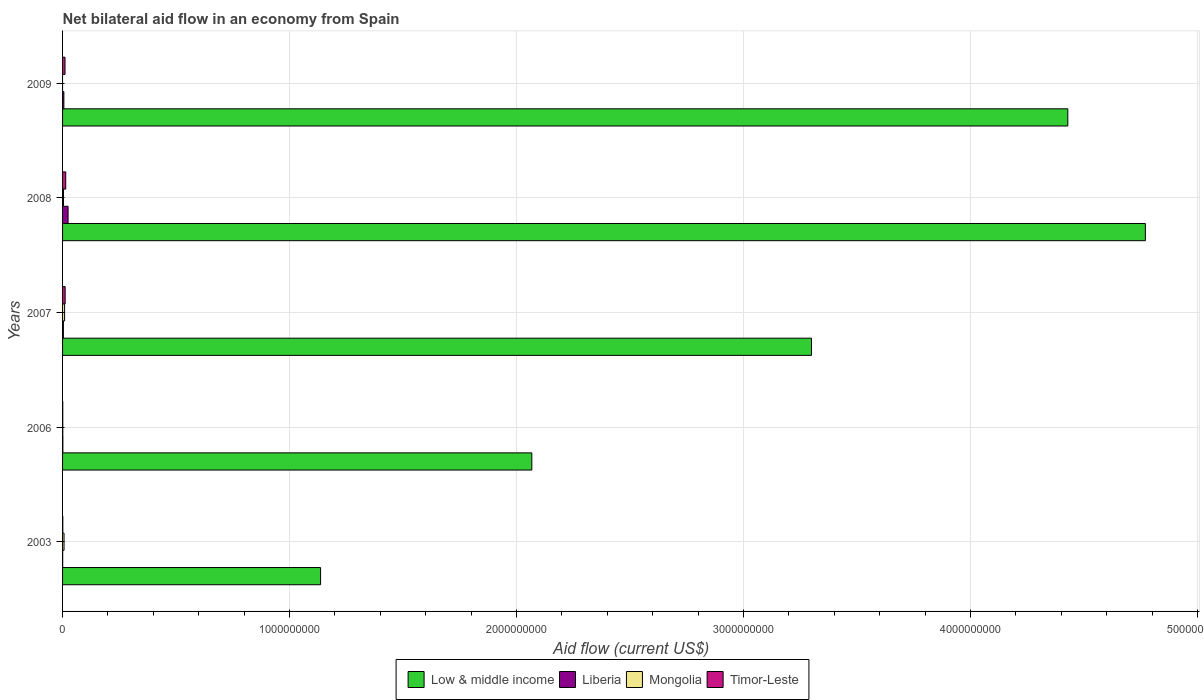How many different coloured bars are there?
Make the answer very short. 4. How many groups of bars are there?
Offer a very short reply. 5. Are the number of bars on each tick of the Y-axis equal?
Your answer should be very brief. No. How many bars are there on the 1st tick from the top?
Ensure brevity in your answer.  3. What is the label of the 3rd group of bars from the top?
Your answer should be compact. 2007. What is the net bilateral aid flow in Mongolia in 2006?
Provide a succinct answer. 8.90e+05. Across all years, what is the maximum net bilateral aid flow in Liberia?
Provide a short and direct response. 2.43e+07. In which year was the net bilateral aid flow in Liberia maximum?
Give a very brief answer. 2008. What is the total net bilateral aid flow in Liberia in the graph?
Provide a short and direct response. 3.53e+07. What is the difference between the net bilateral aid flow in Low & middle income in 2006 and that in 2007?
Provide a succinct answer. -1.23e+09. What is the difference between the net bilateral aid flow in Mongolia in 2006 and the net bilateral aid flow in Timor-Leste in 2007?
Your answer should be compact. -1.05e+07. What is the average net bilateral aid flow in Low & middle income per year?
Make the answer very short. 3.14e+09. In the year 2008, what is the difference between the net bilateral aid flow in Mongolia and net bilateral aid flow in Timor-Leste?
Your response must be concise. -9.91e+06. What is the ratio of the net bilateral aid flow in Timor-Leste in 2003 to that in 2009?
Provide a succinct answer. 0.1. Is the difference between the net bilateral aid flow in Mongolia in 2006 and 2008 greater than the difference between the net bilateral aid flow in Timor-Leste in 2006 and 2008?
Give a very brief answer. Yes. What is the difference between the highest and the second highest net bilateral aid flow in Mongolia?
Your response must be concise. 2.44e+06. What is the difference between the highest and the lowest net bilateral aid flow in Timor-Leste?
Offer a very short reply. 1.32e+07. Is it the case that in every year, the sum of the net bilateral aid flow in Liberia and net bilateral aid flow in Timor-Leste is greater than the sum of net bilateral aid flow in Low & middle income and net bilateral aid flow in Mongolia?
Give a very brief answer. No. Is it the case that in every year, the sum of the net bilateral aid flow in Low & middle income and net bilateral aid flow in Mongolia is greater than the net bilateral aid flow in Timor-Leste?
Keep it short and to the point. Yes. How many years are there in the graph?
Offer a very short reply. 5. What is the difference between two consecutive major ticks on the X-axis?
Give a very brief answer. 1.00e+09. Are the values on the major ticks of X-axis written in scientific E-notation?
Ensure brevity in your answer.  No. Does the graph contain grids?
Provide a short and direct response. Yes. How many legend labels are there?
Make the answer very short. 4. How are the legend labels stacked?
Ensure brevity in your answer.  Horizontal. What is the title of the graph?
Ensure brevity in your answer.  Net bilateral aid flow in an economy from Spain. What is the label or title of the X-axis?
Your answer should be compact. Aid flow (current US$). What is the label or title of the Y-axis?
Your response must be concise. Years. What is the Aid flow (current US$) of Low & middle income in 2003?
Your response must be concise. 1.14e+09. What is the Aid flow (current US$) of Mongolia in 2003?
Give a very brief answer. 6.52e+06. What is the Aid flow (current US$) of Timor-Leste in 2003?
Provide a short and direct response. 1.03e+06. What is the Aid flow (current US$) of Low & middle income in 2006?
Provide a succinct answer. 2.07e+09. What is the Aid flow (current US$) in Liberia in 2006?
Provide a short and direct response. 1.26e+06. What is the Aid flow (current US$) of Mongolia in 2006?
Give a very brief answer. 8.90e+05. What is the Aid flow (current US$) of Timor-Leste in 2006?
Ensure brevity in your answer.  7.90e+05. What is the Aid flow (current US$) of Low & middle income in 2007?
Your answer should be compact. 3.30e+09. What is the Aid flow (current US$) in Liberia in 2007?
Make the answer very short. 3.55e+06. What is the Aid flow (current US$) of Mongolia in 2007?
Offer a very short reply. 8.96e+06. What is the Aid flow (current US$) in Timor-Leste in 2007?
Ensure brevity in your answer.  1.14e+07. What is the Aid flow (current US$) of Low & middle income in 2008?
Keep it short and to the point. 4.77e+09. What is the Aid flow (current US$) of Liberia in 2008?
Provide a succinct answer. 2.43e+07. What is the Aid flow (current US$) in Mongolia in 2008?
Offer a terse response. 4.05e+06. What is the Aid flow (current US$) of Timor-Leste in 2008?
Keep it short and to the point. 1.40e+07. What is the Aid flow (current US$) in Low & middle income in 2009?
Your response must be concise. 4.43e+09. What is the Aid flow (current US$) of Liberia in 2009?
Your response must be concise. 5.75e+06. What is the Aid flow (current US$) of Mongolia in 2009?
Your answer should be very brief. 0. What is the Aid flow (current US$) in Timor-Leste in 2009?
Provide a succinct answer. 1.08e+07. Across all years, what is the maximum Aid flow (current US$) of Low & middle income?
Provide a succinct answer. 4.77e+09. Across all years, what is the maximum Aid flow (current US$) of Liberia?
Keep it short and to the point. 2.43e+07. Across all years, what is the maximum Aid flow (current US$) of Mongolia?
Ensure brevity in your answer.  8.96e+06. Across all years, what is the maximum Aid flow (current US$) in Timor-Leste?
Offer a very short reply. 1.40e+07. Across all years, what is the minimum Aid flow (current US$) in Low & middle income?
Ensure brevity in your answer.  1.14e+09. Across all years, what is the minimum Aid flow (current US$) of Liberia?
Offer a terse response. 4.60e+05. Across all years, what is the minimum Aid flow (current US$) in Timor-Leste?
Offer a terse response. 7.90e+05. What is the total Aid flow (current US$) in Low & middle income in the graph?
Keep it short and to the point. 1.57e+1. What is the total Aid flow (current US$) of Liberia in the graph?
Provide a short and direct response. 3.53e+07. What is the total Aid flow (current US$) in Mongolia in the graph?
Your answer should be very brief. 2.04e+07. What is the total Aid flow (current US$) in Timor-Leste in the graph?
Make the answer very short. 3.80e+07. What is the difference between the Aid flow (current US$) in Low & middle income in 2003 and that in 2006?
Provide a short and direct response. -9.31e+08. What is the difference between the Aid flow (current US$) in Liberia in 2003 and that in 2006?
Provide a short and direct response. -8.00e+05. What is the difference between the Aid flow (current US$) in Mongolia in 2003 and that in 2006?
Offer a terse response. 5.63e+06. What is the difference between the Aid flow (current US$) in Timor-Leste in 2003 and that in 2006?
Provide a succinct answer. 2.40e+05. What is the difference between the Aid flow (current US$) in Low & middle income in 2003 and that in 2007?
Make the answer very short. -2.16e+09. What is the difference between the Aid flow (current US$) in Liberia in 2003 and that in 2007?
Offer a terse response. -3.09e+06. What is the difference between the Aid flow (current US$) in Mongolia in 2003 and that in 2007?
Ensure brevity in your answer.  -2.44e+06. What is the difference between the Aid flow (current US$) in Timor-Leste in 2003 and that in 2007?
Offer a terse response. -1.04e+07. What is the difference between the Aid flow (current US$) of Low & middle income in 2003 and that in 2008?
Your response must be concise. -3.63e+09. What is the difference between the Aid flow (current US$) in Liberia in 2003 and that in 2008?
Your answer should be compact. -2.38e+07. What is the difference between the Aid flow (current US$) of Mongolia in 2003 and that in 2008?
Your answer should be very brief. 2.47e+06. What is the difference between the Aid flow (current US$) in Timor-Leste in 2003 and that in 2008?
Provide a short and direct response. -1.29e+07. What is the difference between the Aid flow (current US$) in Low & middle income in 2003 and that in 2009?
Your answer should be very brief. -3.29e+09. What is the difference between the Aid flow (current US$) in Liberia in 2003 and that in 2009?
Offer a terse response. -5.29e+06. What is the difference between the Aid flow (current US$) in Timor-Leste in 2003 and that in 2009?
Give a very brief answer. -9.79e+06. What is the difference between the Aid flow (current US$) in Low & middle income in 2006 and that in 2007?
Make the answer very short. -1.23e+09. What is the difference between the Aid flow (current US$) of Liberia in 2006 and that in 2007?
Provide a short and direct response. -2.29e+06. What is the difference between the Aid flow (current US$) of Mongolia in 2006 and that in 2007?
Make the answer very short. -8.07e+06. What is the difference between the Aid flow (current US$) in Timor-Leste in 2006 and that in 2007?
Your answer should be compact. -1.06e+07. What is the difference between the Aid flow (current US$) in Low & middle income in 2006 and that in 2008?
Keep it short and to the point. -2.70e+09. What is the difference between the Aid flow (current US$) in Liberia in 2006 and that in 2008?
Make the answer very short. -2.30e+07. What is the difference between the Aid flow (current US$) in Mongolia in 2006 and that in 2008?
Your answer should be compact. -3.16e+06. What is the difference between the Aid flow (current US$) in Timor-Leste in 2006 and that in 2008?
Ensure brevity in your answer.  -1.32e+07. What is the difference between the Aid flow (current US$) of Low & middle income in 2006 and that in 2009?
Offer a very short reply. -2.36e+09. What is the difference between the Aid flow (current US$) of Liberia in 2006 and that in 2009?
Offer a terse response. -4.49e+06. What is the difference between the Aid flow (current US$) in Timor-Leste in 2006 and that in 2009?
Offer a very short reply. -1.00e+07. What is the difference between the Aid flow (current US$) of Low & middle income in 2007 and that in 2008?
Offer a terse response. -1.47e+09. What is the difference between the Aid flow (current US$) of Liberia in 2007 and that in 2008?
Provide a short and direct response. -2.07e+07. What is the difference between the Aid flow (current US$) in Mongolia in 2007 and that in 2008?
Keep it short and to the point. 4.91e+06. What is the difference between the Aid flow (current US$) in Timor-Leste in 2007 and that in 2008?
Make the answer very short. -2.55e+06. What is the difference between the Aid flow (current US$) of Low & middle income in 2007 and that in 2009?
Your response must be concise. -1.13e+09. What is the difference between the Aid flow (current US$) in Liberia in 2007 and that in 2009?
Provide a succinct answer. -2.20e+06. What is the difference between the Aid flow (current US$) of Timor-Leste in 2007 and that in 2009?
Your answer should be very brief. 5.90e+05. What is the difference between the Aid flow (current US$) of Low & middle income in 2008 and that in 2009?
Your answer should be very brief. 3.42e+08. What is the difference between the Aid flow (current US$) of Liberia in 2008 and that in 2009?
Your response must be concise. 1.85e+07. What is the difference between the Aid flow (current US$) in Timor-Leste in 2008 and that in 2009?
Your answer should be very brief. 3.14e+06. What is the difference between the Aid flow (current US$) in Low & middle income in 2003 and the Aid flow (current US$) in Liberia in 2006?
Your response must be concise. 1.14e+09. What is the difference between the Aid flow (current US$) in Low & middle income in 2003 and the Aid flow (current US$) in Mongolia in 2006?
Your answer should be compact. 1.14e+09. What is the difference between the Aid flow (current US$) of Low & middle income in 2003 and the Aid flow (current US$) of Timor-Leste in 2006?
Your answer should be very brief. 1.14e+09. What is the difference between the Aid flow (current US$) of Liberia in 2003 and the Aid flow (current US$) of Mongolia in 2006?
Ensure brevity in your answer.  -4.30e+05. What is the difference between the Aid flow (current US$) in Liberia in 2003 and the Aid flow (current US$) in Timor-Leste in 2006?
Make the answer very short. -3.30e+05. What is the difference between the Aid flow (current US$) of Mongolia in 2003 and the Aid flow (current US$) of Timor-Leste in 2006?
Offer a very short reply. 5.73e+06. What is the difference between the Aid flow (current US$) in Low & middle income in 2003 and the Aid flow (current US$) in Liberia in 2007?
Make the answer very short. 1.13e+09. What is the difference between the Aid flow (current US$) in Low & middle income in 2003 and the Aid flow (current US$) in Mongolia in 2007?
Your response must be concise. 1.13e+09. What is the difference between the Aid flow (current US$) in Low & middle income in 2003 and the Aid flow (current US$) in Timor-Leste in 2007?
Provide a short and direct response. 1.13e+09. What is the difference between the Aid flow (current US$) of Liberia in 2003 and the Aid flow (current US$) of Mongolia in 2007?
Ensure brevity in your answer.  -8.50e+06. What is the difference between the Aid flow (current US$) of Liberia in 2003 and the Aid flow (current US$) of Timor-Leste in 2007?
Provide a short and direct response. -1.10e+07. What is the difference between the Aid flow (current US$) in Mongolia in 2003 and the Aid flow (current US$) in Timor-Leste in 2007?
Your response must be concise. -4.89e+06. What is the difference between the Aid flow (current US$) of Low & middle income in 2003 and the Aid flow (current US$) of Liberia in 2008?
Offer a very short reply. 1.11e+09. What is the difference between the Aid flow (current US$) in Low & middle income in 2003 and the Aid flow (current US$) in Mongolia in 2008?
Make the answer very short. 1.13e+09. What is the difference between the Aid flow (current US$) of Low & middle income in 2003 and the Aid flow (current US$) of Timor-Leste in 2008?
Ensure brevity in your answer.  1.12e+09. What is the difference between the Aid flow (current US$) of Liberia in 2003 and the Aid flow (current US$) of Mongolia in 2008?
Provide a succinct answer. -3.59e+06. What is the difference between the Aid flow (current US$) in Liberia in 2003 and the Aid flow (current US$) in Timor-Leste in 2008?
Make the answer very short. -1.35e+07. What is the difference between the Aid flow (current US$) of Mongolia in 2003 and the Aid flow (current US$) of Timor-Leste in 2008?
Your answer should be compact. -7.44e+06. What is the difference between the Aid flow (current US$) of Low & middle income in 2003 and the Aid flow (current US$) of Liberia in 2009?
Make the answer very short. 1.13e+09. What is the difference between the Aid flow (current US$) of Low & middle income in 2003 and the Aid flow (current US$) of Timor-Leste in 2009?
Your answer should be very brief. 1.13e+09. What is the difference between the Aid flow (current US$) in Liberia in 2003 and the Aid flow (current US$) in Timor-Leste in 2009?
Provide a short and direct response. -1.04e+07. What is the difference between the Aid flow (current US$) in Mongolia in 2003 and the Aid flow (current US$) in Timor-Leste in 2009?
Provide a short and direct response. -4.30e+06. What is the difference between the Aid flow (current US$) of Low & middle income in 2006 and the Aid flow (current US$) of Liberia in 2007?
Keep it short and to the point. 2.06e+09. What is the difference between the Aid flow (current US$) of Low & middle income in 2006 and the Aid flow (current US$) of Mongolia in 2007?
Keep it short and to the point. 2.06e+09. What is the difference between the Aid flow (current US$) in Low & middle income in 2006 and the Aid flow (current US$) in Timor-Leste in 2007?
Your answer should be very brief. 2.06e+09. What is the difference between the Aid flow (current US$) of Liberia in 2006 and the Aid flow (current US$) of Mongolia in 2007?
Provide a short and direct response. -7.70e+06. What is the difference between the Aid flow (current US$) of Liberia in 2006 and the Aid flow (current US$) of Timor-Leste in 2007?
Keep it short and to the point. -1.02e+07. What is the difference between the Aid flow (current US$) in Mongolia in 2006 and the Aid flow (current US$) in Timor-Leste in 2007?
Your answer should be compact. -1.05e+07. What is the difference between the Aid flow (current US$) in Low & middle income in 2006 and the Aid flow (current US$) in Liberia in 2008?
Give a very brief answer. 2.04e+09. What is the difference between the Aid flow (current US$) of Low & middle income in 2006 and the Aid flow (current US$) of Mongolia in 2008?
Give a very brief answer. 2.06e+09. What is the difference between the Aid flow (current US$) of Low & middle income in 2006 and the Aid flow (current US$) of Timor-Leste in 2008?
Ensure brevity in your answer.  2.05e+09. What is the difference between the Aid flow (current US$) of Liberia in 2006 and the Aid flow (current US$) of Mongolia in 2008?
Provide a succinct answer. -2.79e+06. What is the difference between the Aid flow (current US$) of Liberia in 2006 and the Aid flow (current US$) of Timor-Leste in 2008?
Your response must be concise. -1.27e+07. What is the difference between the Aid flow (current US$) of Mongolia in 2006 and the Aid flow (current US$) of Timor-Leste in 2008?
Keep it short and to the point. -1.31e+07. What is the difference between the Aid flow (current US$) in Low & middle income in 2006 and the Aid flow (current US$) in Liberia in 2009?
Offer a very short reply. 2.06e+09. What is the difference between the Aid flow (current US$) in Low & middle income in 2006 and the Aid flow (current US$) in Timor-Leste in 2009?
Ensure brevity in your answer.  2.06e+09. What is the difference between the Aid flow (current US$) of Liberia in 2006 and the Aid flow (current US$) of Timor-Leste in 2009?
Give a very brief answer. -9.56e+06. What is the difference between the Aid flow (current US$) in Mongolia in 2006 and the Aid flow (current US$) in Timor-Leste in 2009?
Your answer should be compact. -9.93e+06. What is the difference between the Aid flow (current US$) in Low & middle income in 2007 and the Aid flow (current US$) in Liberia in 2008?
Provide a short and direct response. 3.28e+09. What is the difference between the Aid flow (current US$) in Low & middle income in 2007 and the Aid flow (current US$) in Mongolia in 2008?
Ensure brevity in your answer.  3.30e+09. What is the difference between the Aid flow (current US$) of Low & middle income in 2007 and the Aid flow (current US$) of Timor-Leste in 2008?
Your answer should be compact. 3.29e+09. What is the difference between the Aid flow (current US$) in Liberia in 2007 and the Aid flow (current US$) in Mongolia in 2008?
Your answer should be very brief. -5.00e+05. What is the difference between the Aid flow (current US$) of Liberia in 2007 and the Aid flow (current US$) of Timor-Leste in 2008?
Offer a very short reply. -1.04e+07. What is the difference between the Aid flow (current US$) in Mongolia in 2007 and the Aid flow (current US$) in Timor-Leste in 2008?
Provide a short and direct response. -5.00e+06. What is the difference between the Aid flow (current US$) of Low & middle income in 2007 and the Aid flow (current US$) of Liberia in 2009?
Keep it short and to the point. 3.29e+09. What is the difference between the Aid flow (current US$) of Low & middle income in 2007 and the Aid flow (current US$) of Timor-Leste in 2009?
Ensure brevity in your answer.  3.29e+09. What is the difference between the Aid flow (current US$) in Liberia in 2007 and the Aid flow (current US$) in Timor-Leste in 2009?
Make the answer very short. -7.27e+06. What is the difference between the Aid flow (current US$) of Mongolia in 2007 and the Aid flow (current US$) of Timor-Leste in 2009?
Your response must be concise. -1.86e+06. What is the difference between the Aid flow (current US$) of Low & middle income in 2008 and the Aid flow (current US$) of Liberia in 2009?
Offer a very short reply. 4.76e+09. What is the difference between the Aid flow (current US$) in Low & middle income in 2008 and the Aid flow (current US$) in Timor-Leste in 2009?
Provide a succinct answer. 4.76e+09. What is the difference between the Aid flow (current US$) of Liberia in 2008 and the Aid flow (current US$) of Timor-Leste in 2009?
Provide a short and direct response. 1.35e+07. What is the difference between the Aid flow (current US$) in Mongolia in 2008 and the Aid flow (current US$) in Timor-Leste in 2009?
Provide a short and direct response. -6.77e+06. What is the average Aid flow (current US$) in Low & middle income per year?
Provide a short and direct response. 3.14e+09. What is the average Aid flow (current US$) of Liberia per year?
Give a very brief answer. 7.06e+06. What is the average Aid flow (current US$) of Mongolia per year?
Give a very brief answer. 4.08e+06. What is the average Aid flow (current US$) in Timor-Leste per year?
Provide a succinct answer. 7.60e+06. In the year 2003, what is the difference between the Aid flow (current US$) in Low & middle income and Aid flow (current US$) in Liberia?
Provide a succinct answer. 1.14e+09. In the year 2003, what is the difference between the Aid flow (current US$) of Low & middle income and Aid flow (current US$) of Mongolia?
Ensure brevity in your answer.  1.13e+09. In the year 2003, what is the difference between the Aid flow (current US$) in Low & middle income and Aid flow (current US$) in Timor-Leste?
Your answer should be very brief. 1.14e+09. In the year 2003, what is the difference between the Aid flow (current US$) of Liberia and Aid flow (current US$) of Mongolia?
Provide a short and direct response. -6.06e+06. In the year 2003, what is the difference between the Aid flow (current US$) of Liberia and Aid flow (current US$) of Timor-Leste?
Make the answer very short. -5.70e+05. In the year 2003, what is the difference between the Aid flow (current US$) in Mongolia and Aid flow (current US$) in Timor-Leste?
Make the answer very short. 5.49e+06. In the year 2006, what is the difference between the Aid flow (current US$) in Low & middle income and Aid flow (current US$) in Liberia?
Your answer should be very brief. 2.07e+09. In the year 2006, what is the difference between the Aid flow (current US$) in Low & middle income and Aid flow (current US$) in Mongolia?
Keep it short and to the point. 2.07e+09. In the year 2006, what is the difference between the Aid flow (current US$) in Low & middle income and Aid flow (current US$) in Timor-Leste?
Give a very brief answer. 2.07e+09. In the year 2006, what is the difference between the Aid flow (current US$) of Liberia and Aid flow (current US$) of Timor-Leste?
Keep it short and to the point. 4.70e+05. In the year 2007, what is the difference between the Aid flow (current US$) of Low & middle income and Aid flow (current US$) of Liberia?
Keep it short and to the point. 3.30e+09. In the year 2007, what is the difference between the Aid flow (current US$) of Low & middle income and Aid flow (current US$) of Mongolia?
Offer a terse response. 3.29e+09. In the year 2007, what is the difference between the Aid flow (current US$) of Low & middle income and Aid flow (current US$) of Timor-Leste?
Your answer should be compact. 3.29e+09. In the year 2007, what is the difference between the Aid flow (current US$) in Liberia and Aid flow (current US$) in Mongolia?
Keep it short and to the point. -5.41e+06. In the year 2007, what is the difference between the Aid flow (current US$) in Liberia and Aid flow (current US$) in Timor-Leste?
Make the answer very short. -7.86e+06. In the year 2007, what is the difference between the Aid flow (current US$) in Mongolia and Aid flow (current US$) in Timor-Leste?
Provide a short and direct response. -2.45e+06. In the year 2008, what is the difference between the Aid flow (current US$) in Low & middle income and Aid flow (current US$) in Liberia?
Provide a succinct answer. 4.75e+09. In the year 2008, what is the difference between the Aid flow (current US$) in Low & middle income and Aid flow (current US$) in Mongolia?
Provide a short and direct response. 4.77e+09. In the year 2008, what is the difference between the Aid flow (current US$) of Low & middle income and Aid flow (current US$) of Timor-Leste?
Make the answer very short. 4.76e+09. In the year 2008, what is the difference between the Aid flow (current US$) of Liberia and Aid flow (current US$) of Mongolia?
Give a very brief answer. 2.02e+07. In the year 2008, what is the difference between the Aid flow (current US$) in Liberia and Aid flow (current US$) in Timor-Leste?
Offer a terse response. 1.03e+07. In the year 2008, what is the difference between the Aid flow (current US$) in Mongolia and Aid flow (current US$) in Timor-Leste?
Provide a succinct answer. -9.91e+06. In the year 2009, what is the difference between the Aid flow (current US$) in Low & middle income and Aid flow (current US$) in Liberia?
Ensure brevity in your answer.  4.42e+09. In the year 2009, what is the difference between the Aid flow (current US$) in Low & middle income and Aid flow (current US$) in Timor-Leste?
Give a very brief answer. 4.42e+09. In the year 2009, what is the difference between the Aid flow (current US$) of Liberia and Aid flow (current US$) of Timor-Leste?
Offer a very short reply. -5.07e+06. What is the ratio of the Aid flow (current US$) in Low & middle income in 2003 to that in 2006?
Provide a succinct answer. 0.55. What is the ratio of the Aid flow (current US$) in Liberia in 2003 to that in 2006?
Offer a very short reply. 0.37. What is the ratio of the Aid flow (current US$) in Mongolia in 2003 to that in 2006?
Keep it short and to the point. 7.33. What is the ratio of the Aid flow (current US$) in Timor-Leste in 2003 to that in 2006?
Offer a very short reply. 1.3. What is the ratio of the Aid flow (current US$) in Low & middle income in 2003 to that in 2007?
Provide a short and direct response. 0.34. What is the ratio of the Aid flow (current US$) of Liberia in 2003 to that in 2007?
Provide a succinct answer. 0.13. What is the ratio of the Aid flow (current US$) of Mongolia in 2003 to that in 2007?
Provide a succinct answer. 0.73. What is the ratio of the Aid flow (current US$) of Timor-Leste in 2003 to that in 2007?
Your response must be concise. 0.09. What is the ratio of the Aid flow (current US$) in Low & middle income in 2003 to that in 2008?
Provide a short and direct response. 0.24. What is the ratio of the Aid flow (current US$) in Liberia in 2003 to that in 2008?
Your answer should be very brief. 0.02. What is the ratio of the Aid flow (current US$) of Mongolia in 2003 to that in 2008?
Keep it short and to the point. 1.61. What is the ratio of the Aid flow (current US$) of Timor-Leste in 2003 to that in 2008?
Offer a very short reply. 0.07. What is the ratio of the Aid flow (current US$) of Low & middle income in 2003 to that in 2009?
Your answer should be compact. 0.26. What is the ratio of the Aid flow (current US$) in Timor-Leste in 2003 to that in 2009?
Give a very brief answer. 0.1. What is the ratio of the Aid flow (current US$) of Low & middle income in 2006 to that in 2007?
Keep it short and to the point. 0.63. What is the ratio of the Aid flow (current US$) in Liberia in 2006 to that in 2007?
Provide a succinct answer. 0.35. What is the ratio of the Aid flow (current US$) of Mongolia in 2006 to that in 2007?
Your answer should be compact. 0.1. What is the ratio of the Aid flow (current US$) of Timor-Leste in 2006 to that in 2007?
Give a very brief answer. 0.07. What is the ratio of the Aid flow (current US$) of Low & middle income in 2006 to that in 2008?
Offer a terse response. 0.43. What is the ratio of the Aid flow (current US$) of Liberia in 2006 to that in 2008?
Provide a short and direct response. 0.05. What is the ratio of the Aid flow (current US$) of Mongolia in 2006 to that in 2008?
Your answer should be compact. 0.22. What is the ratio of the Aid flow (current US$) of Timor-Leste in 2006 to that in 2008?
Offer a very short reply. 0.06. What is the ratio of the Aid flow (current US$) of Low & middle income in 2006 to that in 2009?
Make the answer very short. 0.47. What is the ratio of the Aid flow (current US$) in Liberia in 2006 to that in 2009?
Provide a short and direct response. 0.22. What is the ratio of the Aid flow (current US$) of Timor-Leste in 2006 to that in 2009?
Ensure brevity in your answer.  0.07. What is the ratio of the Aid flow (current US$) in Low & middle income in 2007 to that in 2008?
Give a very brief answer. 0.69. What is the ratio of the Aid flow (current US$) of Liberia in 2007 to that in 2008?
Your answer should be compact. 0.15. What is the ratio of the Aid flow (current US$) in Mongolia in 2007 to that in 2008?
Your answer should be very brief. 2.21. What is the ratio of the Aid flow (current US$) of Timor-Leste in 2007 to that in 2008?
Keep it short and to the point. 0.82. What is the ratio of the Aid flow (current US$) in Low & middle income in 2007 to that in 2009?
Provide a short and direct response. 0.74. What is the ratio of the Aid flow (current US$) of Liberia in 2007 to that in 2009?
Your response must be concise. 0.62. What is the ratio of the Aid flow (current US$) of Timor-Leste in 2007 to that in 2009?
Offer a very short reply. 1.05. What is the ratio of the Aid flow (current US$) in Low & middle income in 2008 to that in 2009?
Keep it short and to the point. 1.08. What is the ratio of the Aid flow (current US$) in Liberia in 2008 to that in 2009?
Your answer should be very brief. 4.22. What is the ratio of the Aid flow (current US$) of Timor-Leste in 2008 to that in 2009?
Keep it short and to the point. 1.29. What is the difference between the highest and the second highest Aid flow (current US$) of Low & middle income?
Keep it short and to the point. 3.42e+08. What is the difference between the highest and the second highest Aid flow (current US$) in Liberia?
Your answer should be very brief. 1.85e+07. What is the difference between the highest and the second highest Aid flow (current US$) of Mongolia?
Offer a very short reply. 2.44e+06. What is the difference between the highest and the second highest Aid flow (current US$) of Timor-Leste?
Ensure brevity in your answer.  2.55e+06. What is the difference between the highest and the lowest Aid flow (current US$) of Low & middle income?
Keep it short and to the point. 3.63e+09. What is the difference between the highest and the lowest Aid flow (current US$) of Liberia?
Your answer should be very brief. 2.38e+07. What is the difference between the highest and the lowest Aid flow (current US$) in Mongolia?
Offer a very short reply. 8.96e+06. What is the difference between the highest and the lowest Aid flow (current US$) of Timor-Leste?
Provide a short and direct response. 1.32e+07. 